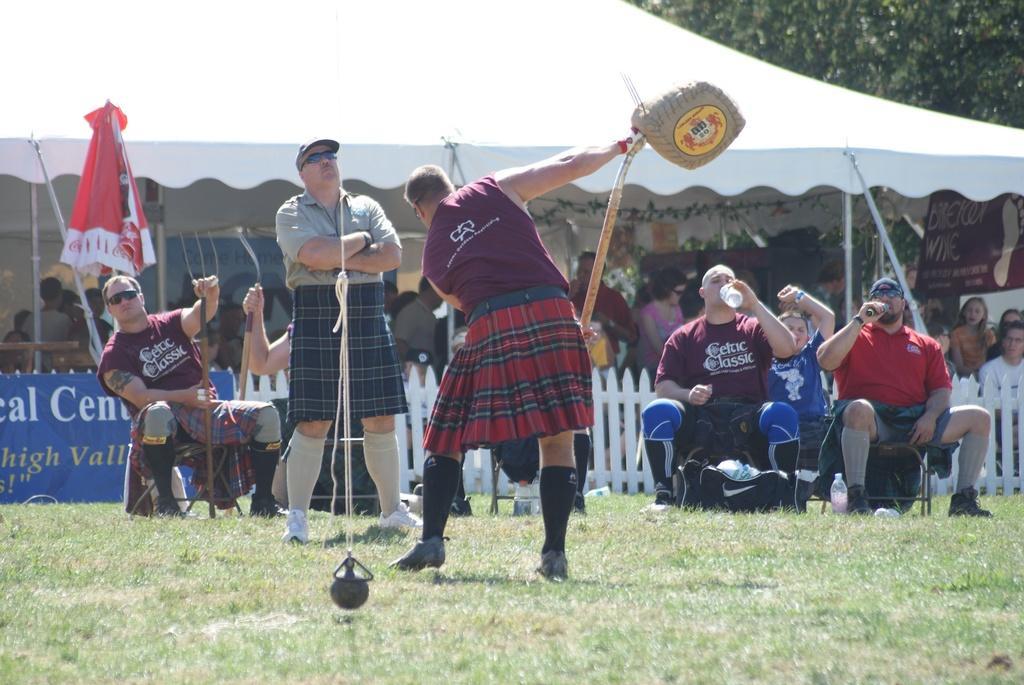Could you give a brief overview of what you see in this image? A person is performing some activity and around him the crowd is enjoying the play and all of them are gathered in an open area and the climate is sunny. 